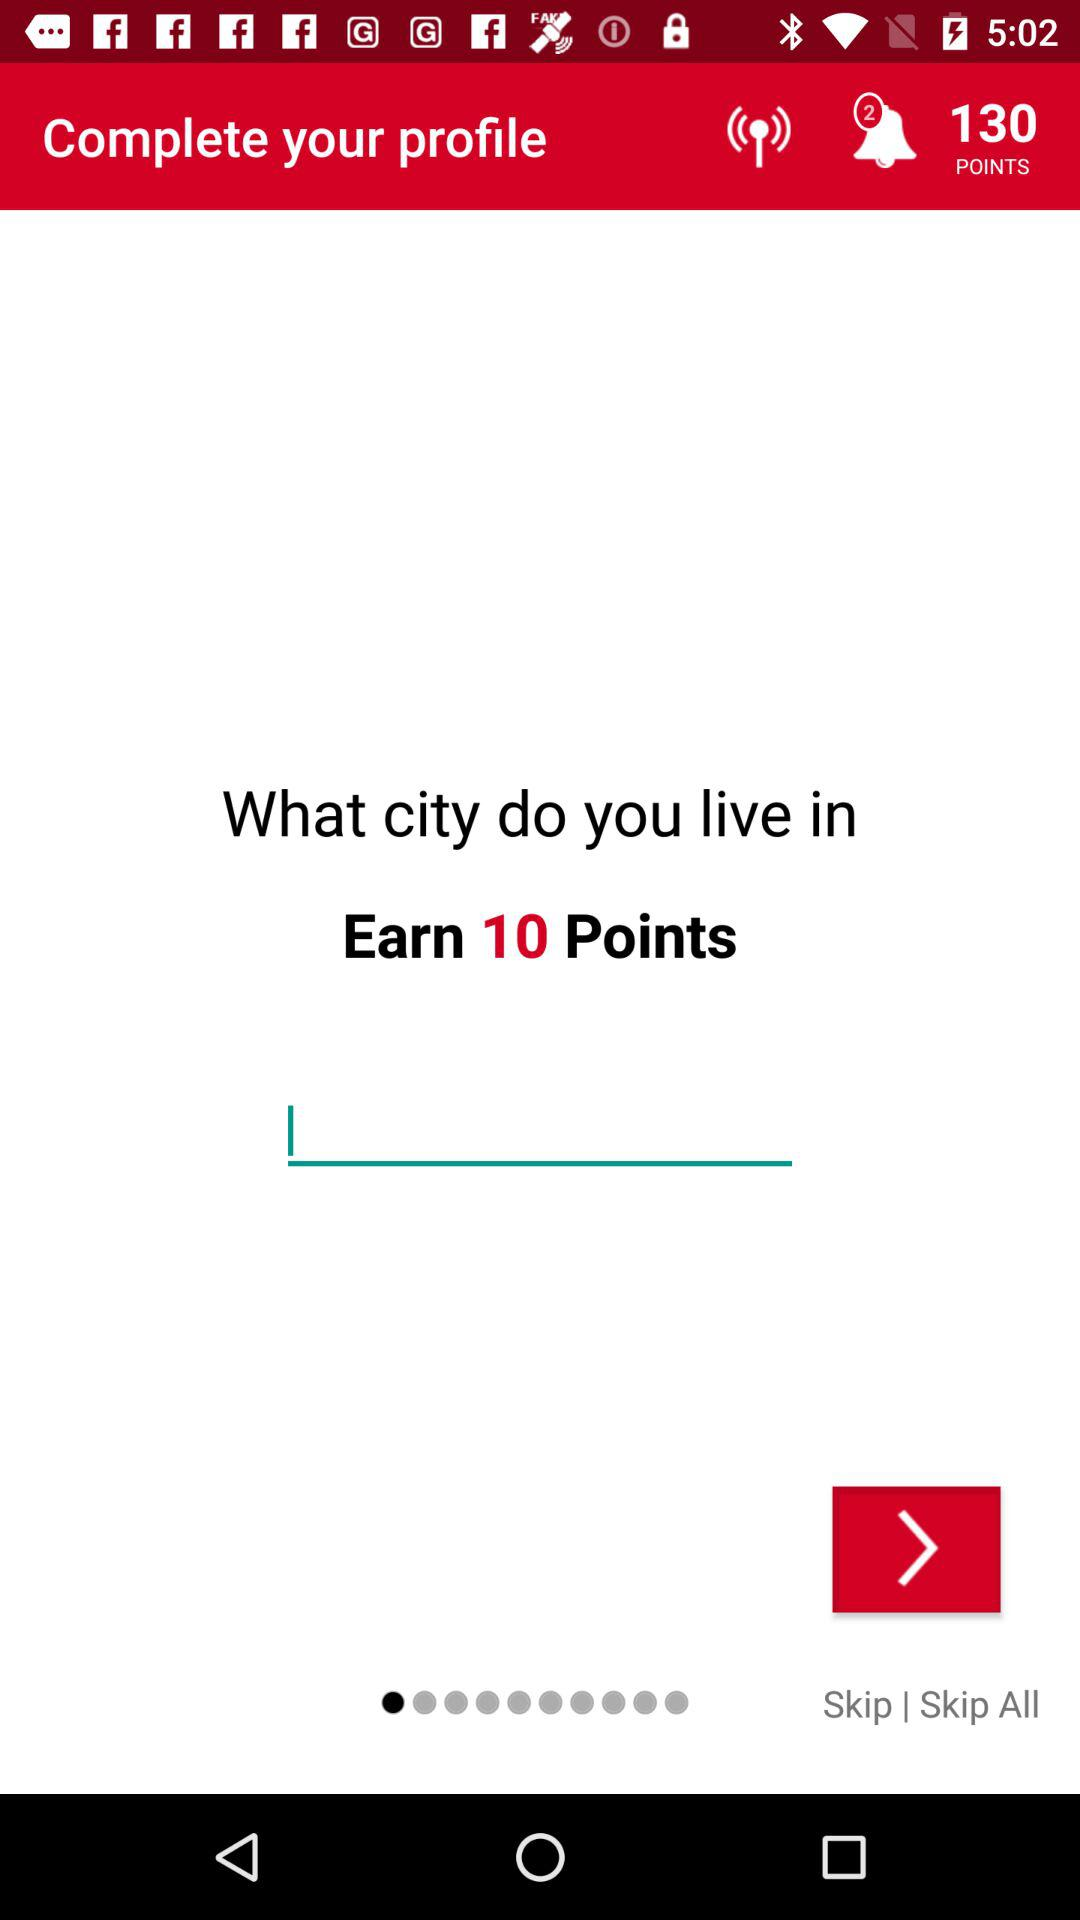How many points are already there? There are already 130 points. 